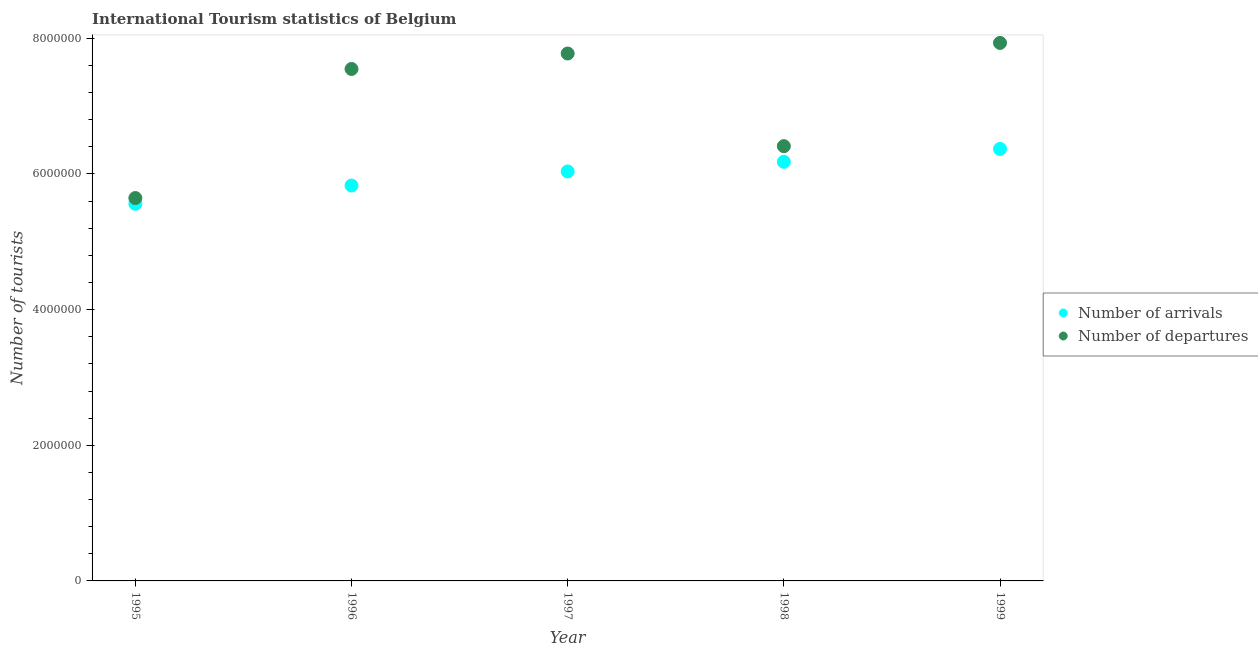What is the number of tourist arrivals in 1996?
Ensure brevity in your answer.  5.83e+06. Across all years, what is the maximum number of tourist arrivals?
Keep it short and to the point. 6.37e+06. Across all years, what is the minimum number of tourist arrivals?
Give a very brief answer. 5.56e+06. In which year was the number of tourist departures maximum?
Your response must be concise. 1999. What is the total number of tourist departures in the graph?
Your response must be concise. 3.53e+07. What is the difference between the number of tourist departures in 1996 and that in 1997?
Keep it short and to the point. -2.28e+05. What is the difference between the number of tourist arrivals in 1997 and the number of tourist departures in 1996?
Give a very brief answer. -1.51e+06. What is the average number of tourist departures per year?
Your answer should be very brief. 7.06e+06. In the year 1996, what is the difference between the number of tourist arrivals and number of tourist departures?
Your answer should be very brief. -1.72e+06. In how many years, is the number of tourist arrivals greater than 3200000?
Ensure brevity in your answer.  5. What is the ratio of the number of tourist arrivals in 1995 to that in 1999?
Your response must be concise. 0.87. What is the difference between the highest and the lowest number of tourist arrivals?
Your answer should be very brief. 8.09e+05. In how many years, is the number of tourist departures greater than the average number of tourist departures taken over all years?
Your response must be concise. 3. Is the number of tourist arrivals strictly less than the number of tourist departures over the years?
Your response must be concise. Yes. Are the values on the major ticks of Y-axis written in scientific E-notation?
Offer a terse response. No. Does the graph contain any zero values?
Provide a succinct answer. No. How are the legend labels stacked?
Your answer should be compact. Vertical. What is the title of the graph?
Give a very brief answer. International Tourism statistics of Belgium. What is the label or title of the Y-axis?
Your response must be concise. Number of tourists. What is the Number of tourists of Number of arrivals in 1995?
Offer a terse response. 5.56e+06. What is the Number of tourists of Number of departures in 1995?
Keep it short and to the point. 5.64e+06. What is the Number of tourists of Number of arrivals in 1996?
Ensure brevity in your answer.  5.83e+06. What is the Number of tourists of Number of departures in 1996?
Ensure brevity in your answer.  7.55e+06. What is the Number of tourists of Number of arrivals in 1997?
Your response must be concise. 6.04e+06. What is the Number of tourists in Number of departures in 1997?
Give a very brief answer. 7.78e+06. What is the Number of tourists of Number of arrivals in 1998?
Make the answer very short. 6.18e+06. What is the Number of tourists in Number of departures in 1998?
Your answer should be compact. 6.41e+06. What is the Number of tourists in Number of arrivals in 1999?
Your response must be concise. 6.37e+06. What is the Number of tourists of Number of departures in 1999?
Provide a succinct answer. 7.93e+06. Across all years, what is the maximum Number of tourists of Number of arrivals?
Ensure brevity in your answer.  6.37e+06. Across all years, what is the maximum Number of tourists of Number of departures?
Make the answer very short. 7.93e+06. Across all years, what is the minimum Number of tourists in Number of arrivals?
Make the answer very short. 5.56e+06. Across all years, what is the minimum Number of tourists in Number of departures?
Ensure brevity in your answer.  5.64e+06. What is the total Number of tourists in Number of arrivals in the graph?
Provide a short and direct response. 3.00e+07. What is the total Number of tourists in Number of departures in the graph?
Provide a succinct answer. 3.53e+07. What is the difference between the Number of tourists of Number of arrivals in 1995 and that in 1996?
Keep it short and to the point. -2.69e+05. What is the difference between the Number of tourists in Number of departures in 1995 and that in 1996?
Your answer should be very brief. -1.90e+06. What is the difference between the Number of tourists of Number of arrivals in 1995 and that in 1997?
Keep it short and to the point. -4.77e+05. What is the difference between the Number of tourists of Number of departures in 1995 and that in 1997?
Provide a short and direct response. -2.13e+06. What is the difference between the Number of tourists in Number of arrivals in 1995 and that in 1998?
Offer a terse response. -6.19e+05. What is the difference between the Number of tourists in Number of departures in 1995 and that in 1998?
Your answer should be very brief. -7.65e+05. What is the difference between the Number of tourists in Number of arrivals in 1995 and that in 1999?
Offer a very short reply. -8.09e+05. What is the difference between the Number of tourists in Number of departures in 1995 and that in 1999?
Your answer should be very brief. -2.29e+06. What is the difference between the Number of tourists in Number of arrivals in 1996 and that in 1997?
Your response must be concise. -2.08e+05. What is the difference between the Number of tourists in Number of departures in 1996 and that in 1997?
Keep it short and to the point. -2.28e+05. What is the difference between the Number of tourists of Number of arrivals in 1996 and that in 1998?
Your answer should be compact. -3.50e+05. What is the difference between the Number of tourists of Number of departures in 1996 and that in 1998?
Keep it short and to the point. 1.14e+06. What is the difference between the Number of tourists of Number of arrivals in 1996 and that in 1999?
Offer a terse response. -5.40e+05. What is the difference between the Number of tourists of Number of departures in 1996 and that in 1999?
Your answer should be compact. -3.84e+05. What is the difference between the Number of tourists of Number of arrivals in 1997 and that in 1998?
Provide a succinct answer. -1.42e+05. What is the difference between the Number of tourists in Number of departures in 1997 and that in 1998?
Ensure brevity in your answer.  1.37e+06. What is the difference between the Number of tourists in Number of arrivals in 1997 and that in 1999?
Keep it short and to the point. -3.32e+05. What is the difference between the Number of tourists in Number of departures in 1997 and that in 1999?
Your answer should be very brief. -1.56e+05. What is the difference between the Number of tourists in Number of arrivals in 1998 and that in 1999?
Give a very brief answer. -1.90e+05. What is the difference between the Number of tourists in Number of departures in 1998 and that in 1999?
Ensure brevity in your answer.  -1.52e+06. What is the difference between the Number of tourists in Number of arrivals in 1995 and the Number of tourists in Number of departures in 1996?
Give a very brief answer. -1.99e+06. What is the difference between the Number of tourists of Number of arrivals in 1995 and the Number of tourists of Number of departures in 1997?
Your response must be concise. -2.22e+06. What is the difference between the Number of tourists of Number of arrivals in 1995 and the Number of tourists of Number of departures in 1998?
Your response must be concise. -8.50e+05. What is the difference between the Number of tourists of Number of arrivals in 1995 and the Number of tourists of Number of departures in 1999?
Make the answer very short. -2.37e+06. What is the difference between the Number of tourists of Number of arrivals in 1996 and the Number of tourists of Number of departures in 1997?
Your answer should be compact. -1.95e+06. What is the difference between the Number of tourists in Number of arrivals in 1996 and the Number of tourists in Number of departures in 1998?
Your answer should be compact. -5.81e+05. What is the difference between the Number of tourists in Number of arrivals in 1996 and the Number of tourists in Number of departures in 1999?
Provide a short and direct response. -2.10e+06. What is the difference between the Number of tourists in Number of arrivals in 1997 and the Number of tourists in Number of departures in 1998?
Offer a very short reply. -3.73e+05. What is the difference between the Number of tourists of Number of arrivals in 1997 and the Number of tourists of Number of departures in 1999?
Make the answer very short. -1.90e+06. What is the difference between the Number of tourists of Number of arrivals in 1998 and the Number of tourists of Number of departures in 1999?
Offer a terse response. -1.75e+06. What is the average Number of tourists of Number of arrivals per year?
Ensure brevity in your answer.  5.99e+06. What is the average Number of tourists in Number of departures per year?
Ensure brevity in your answer.  7.06e+06. In the year 1995, what is the difference between the Number of tourists of Number of arrivals and Number of tourists of Number of departures?
Provide a short and direct response. -8.50e+04. In the year 1996, what is the difference between the Number of tourists of Number of arrivals and Number of tourists of Number of departures?
Keep it short and to the point. -1.72e+06. In the year 1997, what is the difference between the Number of tourists in Number of arrivals and Number of tourists in Number of departures?
Ensure brevity in your answer.  -1.74e+06. In the year 1998, what is the difference between the Number of tourists in Number of arrivals and Number of tourists in Number of departures?
Give a very brief answer. -2.31e+05. In the year 1999, what is the difference between the Number of tourists in Number of arrivals and Number of tourists in Number of departures?
Provide a short and direct response. -1.56e+06. What is the ratio of the Number of tourists of Number of arrivals in 1995 to that in 1996?
Offer a terse response. 0.95. What is the ratio of the Number of tourists in Number of departures in 1995 to that in 1996?
Keep it short and to the point. 0.75. What is the ratio of the Number of tourists in Number of arrivals in 1995 to that in 1997?
Give a very brief answer. 0.92. What is the ratio of the Number of tourists in Number of departures in 1995 to that in 1997?
Your answer should be compact. 0.73. What is the ratio of the Number of tourists in Number of arrivals in 1995 to that in 1998?
Your answer should be compact. 0.9. What is the ratio of the Number of tourists in Number of departures in 1995 to that in 1998?
Provide a succinct answer. 0.88. What is the ratio of the Number of tourists of Number of arrivals in 1995 to that in 1999?
Offer a terse response. 0.87. What is the ratio of the Number of tourists in Number of departures in 1995 to that in 1999?
Provide a short and direct response. 0.71. What is the ratio of the Number of tourists of Number of arrivals in 1996 to that in 1997?
Offer a very short reply. 0.97. What is the ratio of the Number of tourists of Number of departures in 1996 to that in 1997?
Offer a terse response. 0.97. What is the ratio of the Number of tourists in Number of arrivals in 1996 to that in 1998?
Give a very brief answer. 0.94. What is the ratio of the Number of tourists of Number of departures in 1996 to that in 1998?
Your answer should be compact. 1.18. What is the ratio of the Number of tourists of Number of arrivals in 1996 to that in 1999?
Offer a terse response. 0.92. What is the ratio of the Number of tourists in Number of departures in 1996 to that in 1999?
Offer a very short reply. 0.95. What is the ratio of the Number of tourists in Number of departures in 1997 to that in 1998?
Offer a terse response. 1.21. What is the ratio of the Number of tourists in Number of arrivals in 1997 to that in 1999?
Offer a terse response. 0.95. What is the ratio of the Number of tourists in Number of departures in 1997 to that in 1999?
Ensure brevity in your answer.  0.98. What is the ratio of the Number of tourists of Number of arrivals in 1998 to that in 1999?
Keep it short and to the point. 0.97. What is the ratio of the Number of tourists in Number of departures in 1998 to that in 1999?
Your response must be concise. 0.81. What is the difference between the highest and the second highest Number of tourists of Number of departures?
Ensure brevity in your answer.  1.56e+05. What is the difference between the highest and the lowest Number of tourists of Number of arrivals?
Your answer should be very brief. 8.09e+05. What is the difference between the highest and the lowest Number of tourists in Number of departures?
Make the answer very short. 2.29e+06. 